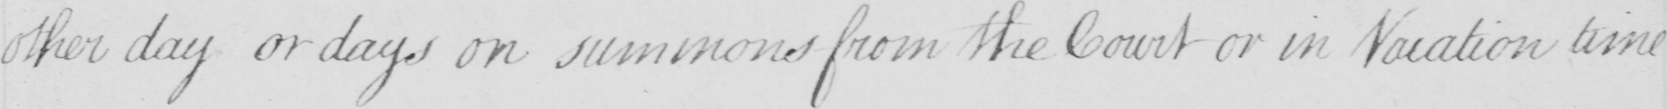What text is written in this handwritten line? other day or days on summons from the Court or in Vacation time 